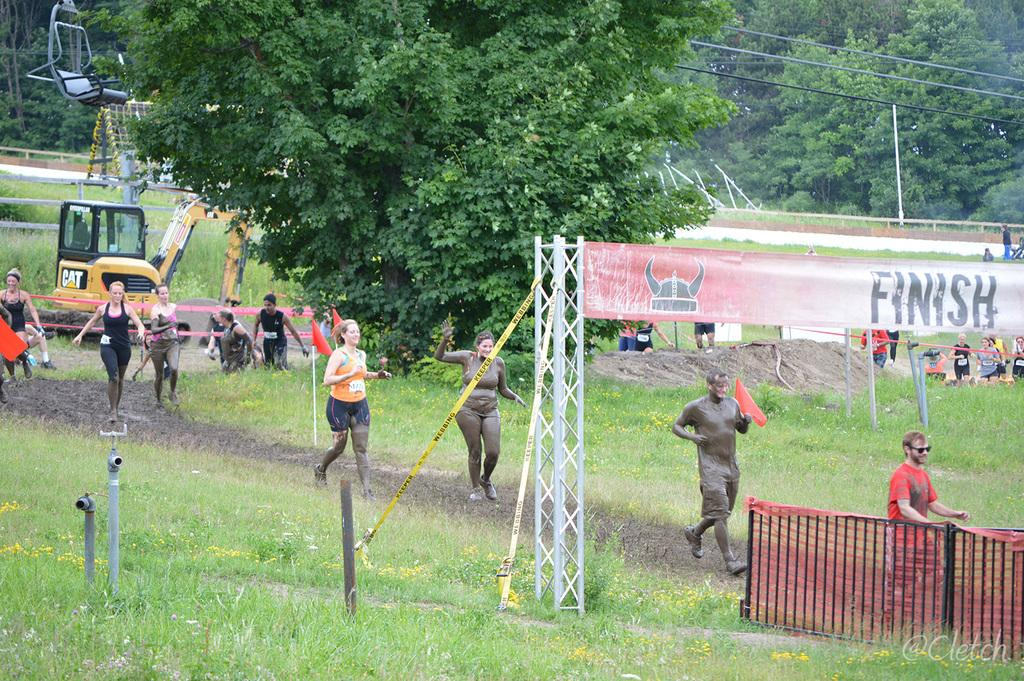<image>
Render a clear and concise summary of the photo. Several people are shown approaching the finish line. 